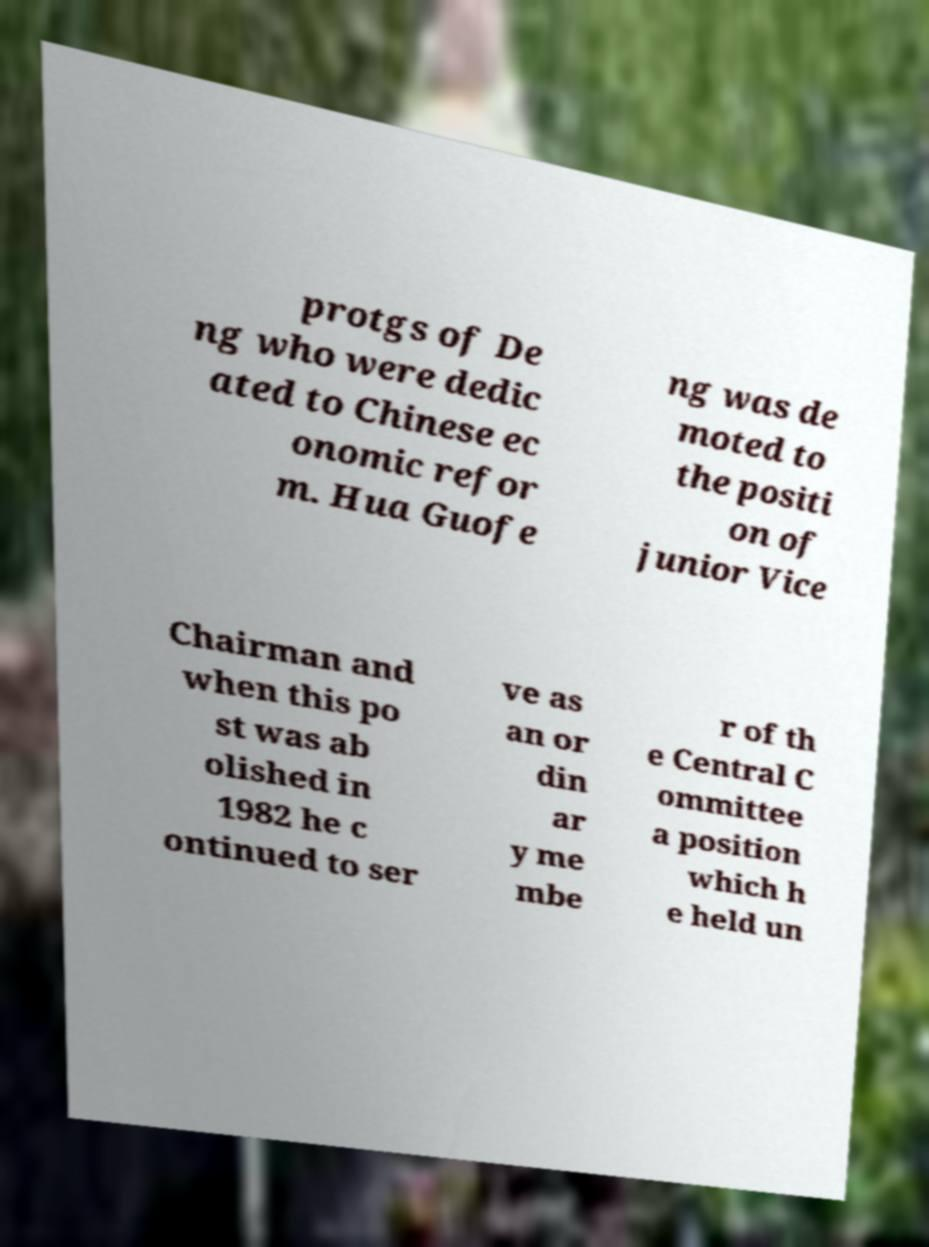What messages or text are displayed in this image? I need them in a readable, typed format. protgs of De ng who were dedic ated to Chinese ec onomic refor m. Hua Guofe ng was de moted to the positi on of junior Vice Chairman and when this po st was ab olished in 1982 he c ontinued to ser ve as an or din ar y me mbe r of th e Central C ommittee a position which h e held un 